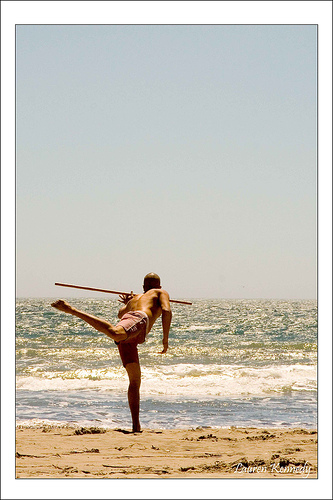<image>
Can you confirm if the man is under the water? No. The man is not positioned under the water. The vertical relationship between these objects is different. Is the man in front of the water? Yes. The man is positioned in front of the water, appearing closer to the camera viewpoint. 